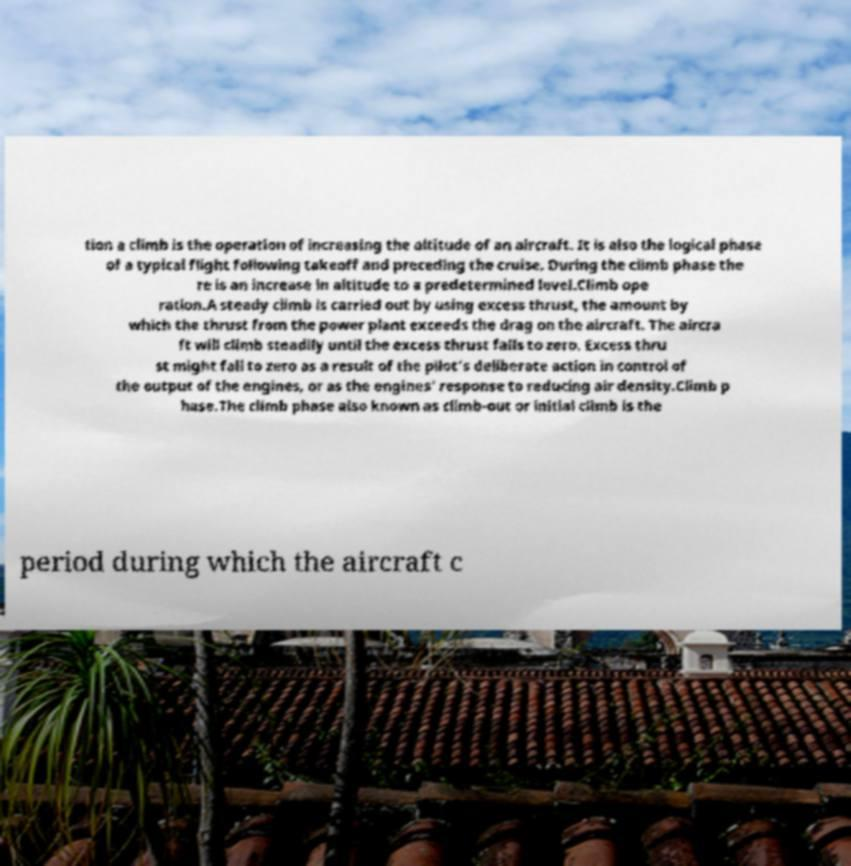Could you assist in decoding the text presented in this image and type it out clearly? tion a climb is the operation of increasing the altitude of an aircraft. It is also the logical phase of a typical flight following takeoff and preceding the cruise. During the climb phase the re is an increase in altitude to a predetermined level.Climb ope ration.A steady climb is carried out by using excess thrust, the amount by which the thrust from the power plant exceeds the drag on the aircraft. The aircra ft will climb steadily until the excess thrust falls to zero. Excess thru st might fall to zero as a result of the pilot's deliberate action in control of the output of the engines, or as the engines' response to reducing air density.Climb p hase.The climb phase also known as climb-out or initial climb is the period during which the aircraft c 